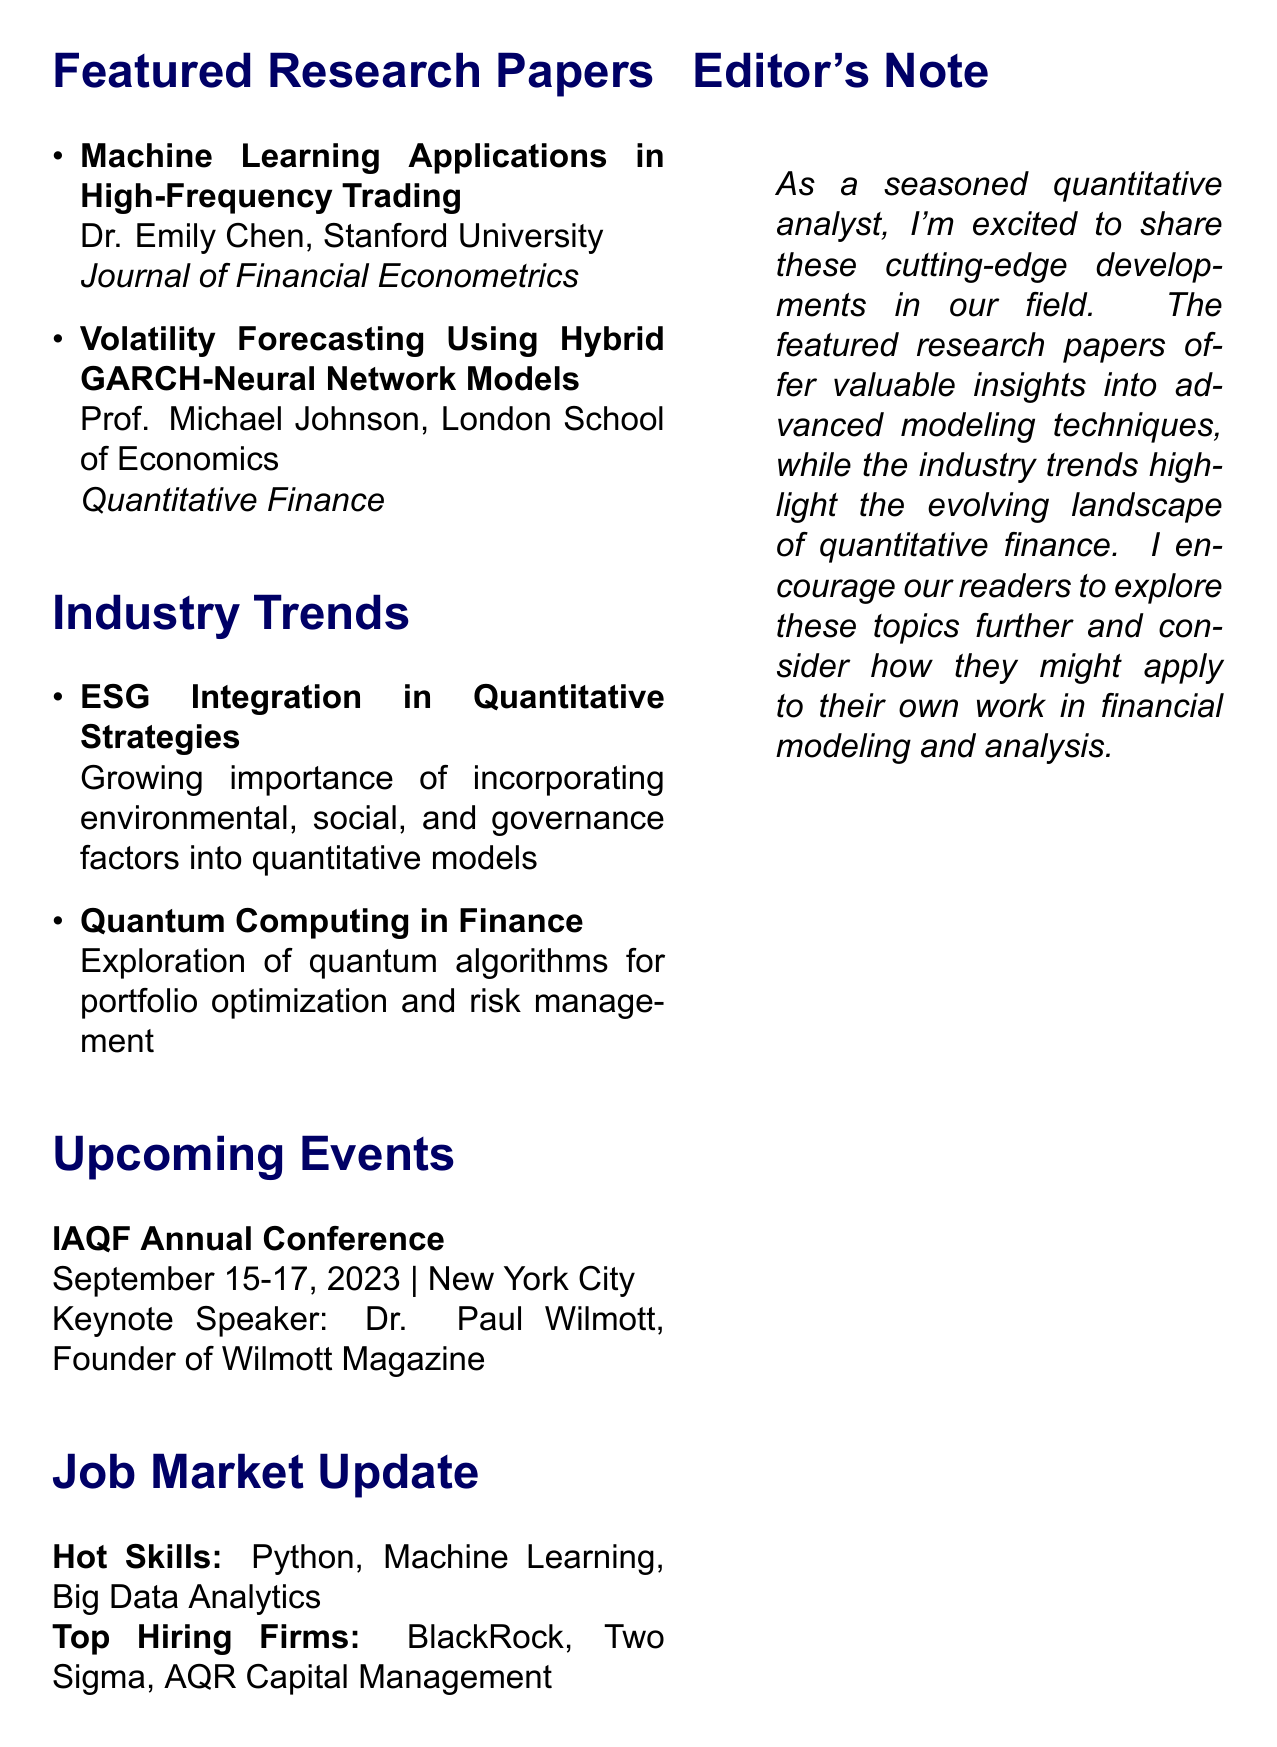What is the title of the newsletter? The title of the newsletter is stated at the top of the document.
Answer: IAQF Quarterly Insights Who is the author of the first featured research paper? The first featured research paper lists the author directly below the title in the document.
Answer: Dr. Emily Chen When is the IAQF Annual Conference scheduled? The date of the upcoming event is specifically mentioned in the event section of the document.
Answer: September 15-17, 2023 What is one of the hot skills in the job market update? The document explicitly lists the skills in the job market update section.
Answer: Python What is the main trend discussed related to ESG? The industry trends section in the document discusses various trends and provides a specific description.
Answer: ESG Integration in Quantitative Strategies Who is the keynote speaker for the upcoming conference? The keynote speaker information is provided in the events section of the newsletter.
Answer: Dr. Paul Wilmott What is the journal for the second featured research paper? The journal name is listed directly along with the research paper details in the document.
Answer: Quantitative Finance What is the focus of the quantum computing trend? The description of the trend is found in the industry trends section.
Answer: Quantum algorithms for portfolio optimization and risk management What is the editor's note about? The editor's note summarizes the content of the newsletter and encourages readers, highlighting key aspects.
Answer: Excitement about cutting-edge developments in quantitative finance 